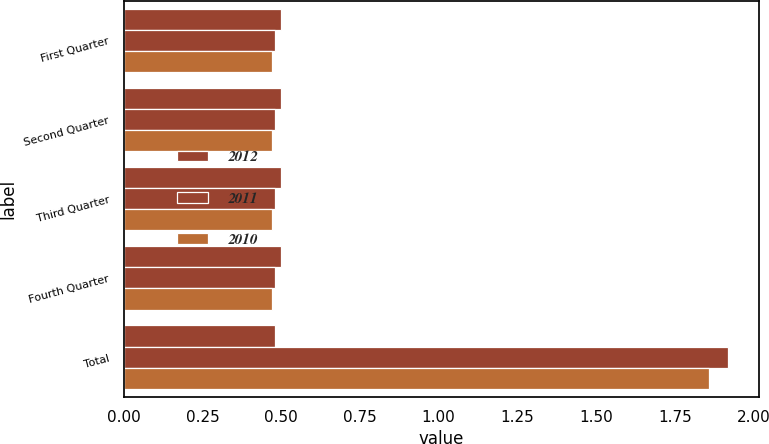Convert chart. <chart><loc_0><loc_0><loc_500><loc_500><stacked_bar_chart><ecel><fcel>First Quarter<fcel>Second Quarter<fcel>Third Quarter<fcel>Fourth Quarter<fcel>Total<nl><fcel>2012<fcel>0.5<fcel>0.5<fcel>0.5<fcel>0.5<fcel>0.48<nl><fcel>2011<fcel>0.48<fcel>0.48<fcel>0.48<fcel>0.48<fcel>1.92<nl><fcel>2010<fcel>0.47<fcel>0.47<fcel>0.47<fcel>0.47<fcel>1.86<nl></chart> 